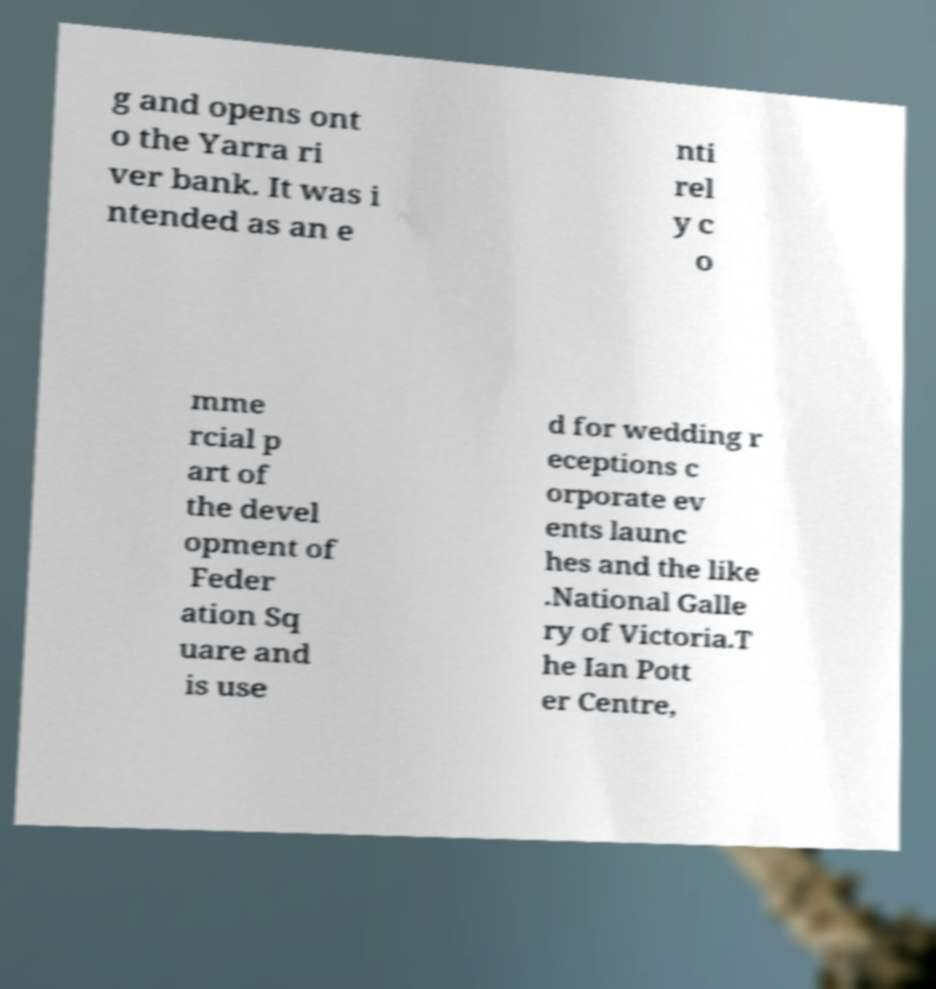For documentation purposes, I need the text within this image transcribed. Could you provide that? g and opens ont o the Yarra ri ver bank. It was i ntended as an e nti rel y c o mme rcial p art of the devel opment of Feder ation Sq uare and is use d for wedding r eceptions c orporate ev ents launc hes and the like .National Galle ry of Victoria.T he Ian Pott er Centre, 